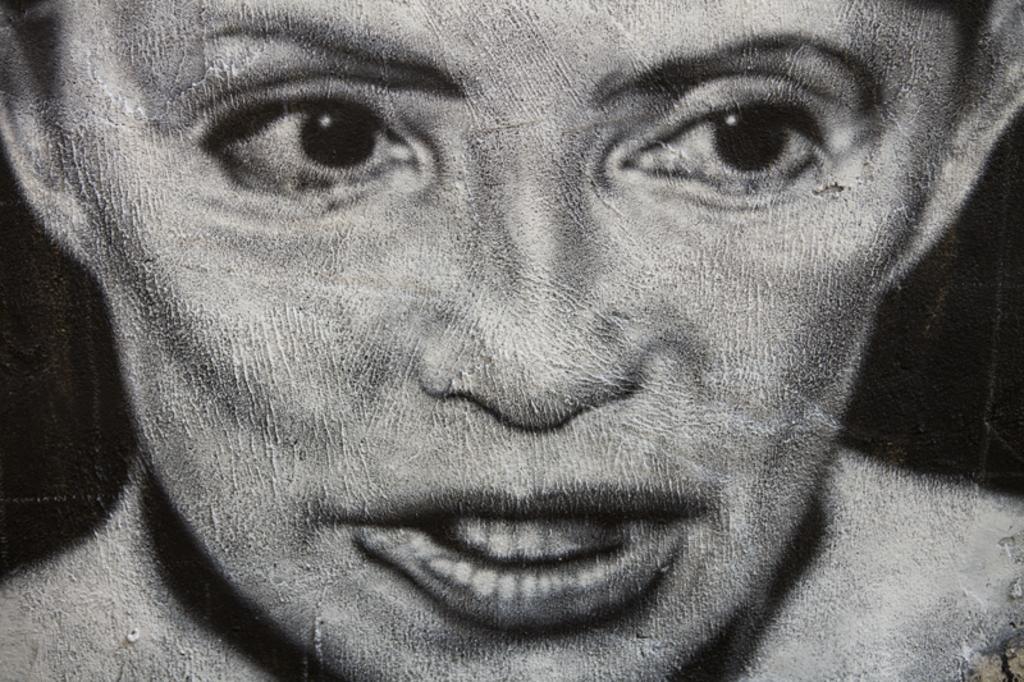Could you give a brief overview of what you see in this image? This image consists of a picture of a woman. The background is dark. 